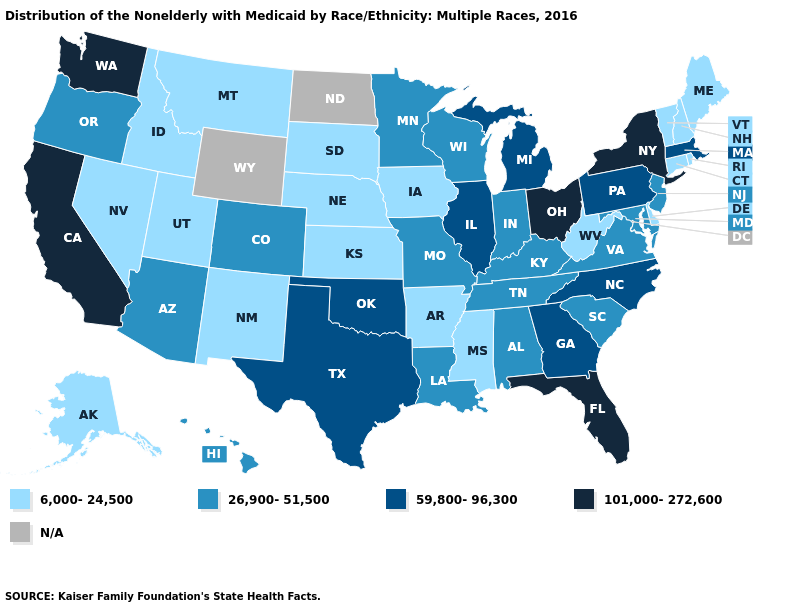What is the value of Washington?
Quick response, please. 101,000-272,600. Among the states that border Tennessee , which have the highest value?
Answer briefly. Georgia, North Carolina. What is the value of North Dakota?
Give a very brief answer. N/A. What is the lowest value in states that border Wyoming?
Short answer required. 6,000-24,500. Name the states that have a value in the range 101,000-272,600?
Be succinct. California, Florida, New York, Ohio, Washington. What is the highest value in the USA?
Give a very brief answer. 101,000-272,600. Name the states that have a value in the range 26,900-51,500?
Give a very brief answer. Alabama, Arizona, Colorado, Hawaii, Indiana, Kentucky, Louisiana, Maryland, Minnesota, Missouri, New Jersey, Oregon, South Carolina, Tennessee, Virginia, Wisconsin. What is the value of Illinois?
Concise answer only. 59,800-96,300. What is the value of Hawaii?
Concise answer only. 26,900-51,500. What is the value of West Virginia?
Concise answer only. 6,000-24,500. Which states have the lowest value in the MidWest?
Concise answer only. Iowa, Kansas, Nebraska, South Dakota. Does the map have missing data?
Short answer required. Yes. What is the lowest value in states that border Minnesota?
Be succinct. 6,000-24,500. What is the value of Nebraska?
Keep it brief. 6,000-24,500. 